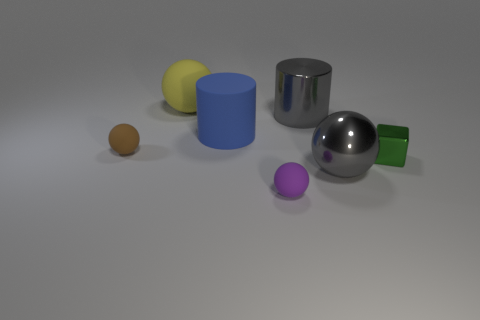Is the color of the shiny cylinder the same as the large metallic sphere?
Your response must be concise. Yes. Are there any big yellow spheres?
Keep it short and to the point. Yes. What number of objects are either large rubber objects that are behind the large matte cylinder or small red metallic things?
Keep it short and to the point. 1. There is a big shiny ball; is it the same color as the large cylinder that is right of the purple ball?
Ensure brevity in your answer.  Yes. Are there any purple objects that have the same size as the cube?
Make the answer very short. Yes. The large cylinder in front of the large gray object behind the green object is made of what material?
Your answer should be compact. Rubber. What number of things have the same color as the metallic cylinder?
Offer a very short reply. 1. There is a big thing that is the same material as the big yellow sphere; what is its shape?
Provide a succinct answer. Cylinder. There is a object that is on the left side of the yellow matte thing; how big is it?
Offer a terse response. Small. Are there the same number of tiny green metallic things that are on the left side of the green shiny cube and small green metallic cubes that are to the right of the small brown rubber thing?
Offer a terse response. No. 